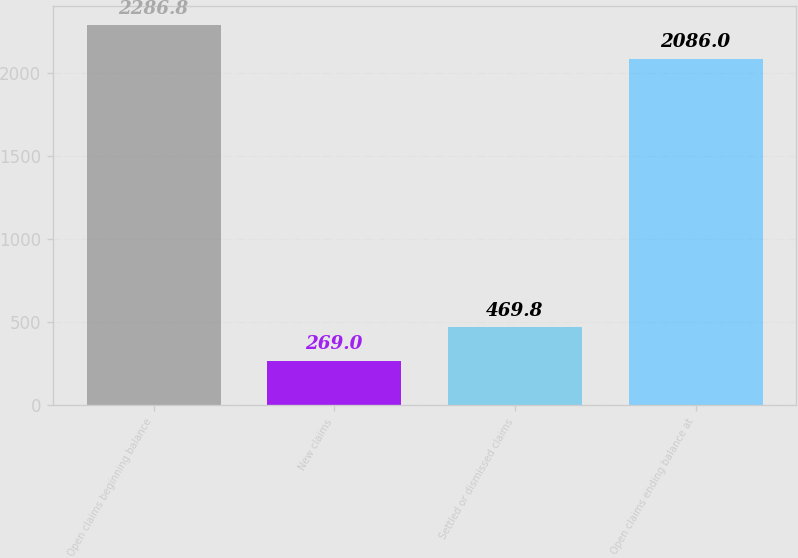Convert chart to OTSL. <chart><loc_0><loc_0><loc_500><loc_500><bar_chart><fcel>Open claims beginning balance<fcel>New claims<fcel>Settled or dismissed claims<fcel>Open claims ending balance at<nl><fcel>2286.8<fcel>269<fcel>469.8<fcel>2086<nl></chart> 